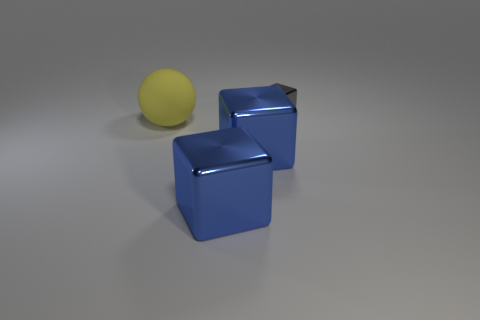Subtract all large blocks. How many blocks are left? 1 Subtract all cubes. How many objects are left? 1 Subtract all gray cubes. How many cubes are left? 2 Add 1 large blue objects. How many objects exist? 5 Add 3 large shiny blocks. How many large shiny blocks exist? 5 Subtract 0 cyan cylinders. How many objects are left? 4 Subtract 3 cubes. How many cubes are left? 0 Subtract all purple blocks. Subtract all purple cylinders. How many blocks are left? 3 Subtract all green balls. How many green cubes are left? 0 Subtract all gray metallic blocks. Subtract all big blue metallic cubes. How many objects are left? 1 